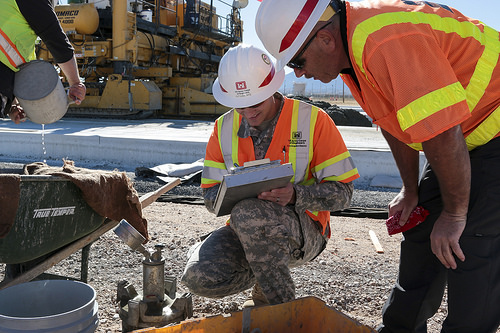<image>
Is the hard hat on the man? No. The hard hat is not positioned on the man. They may be near each other, but the hard hat is not supported by or resting on top of the man. 